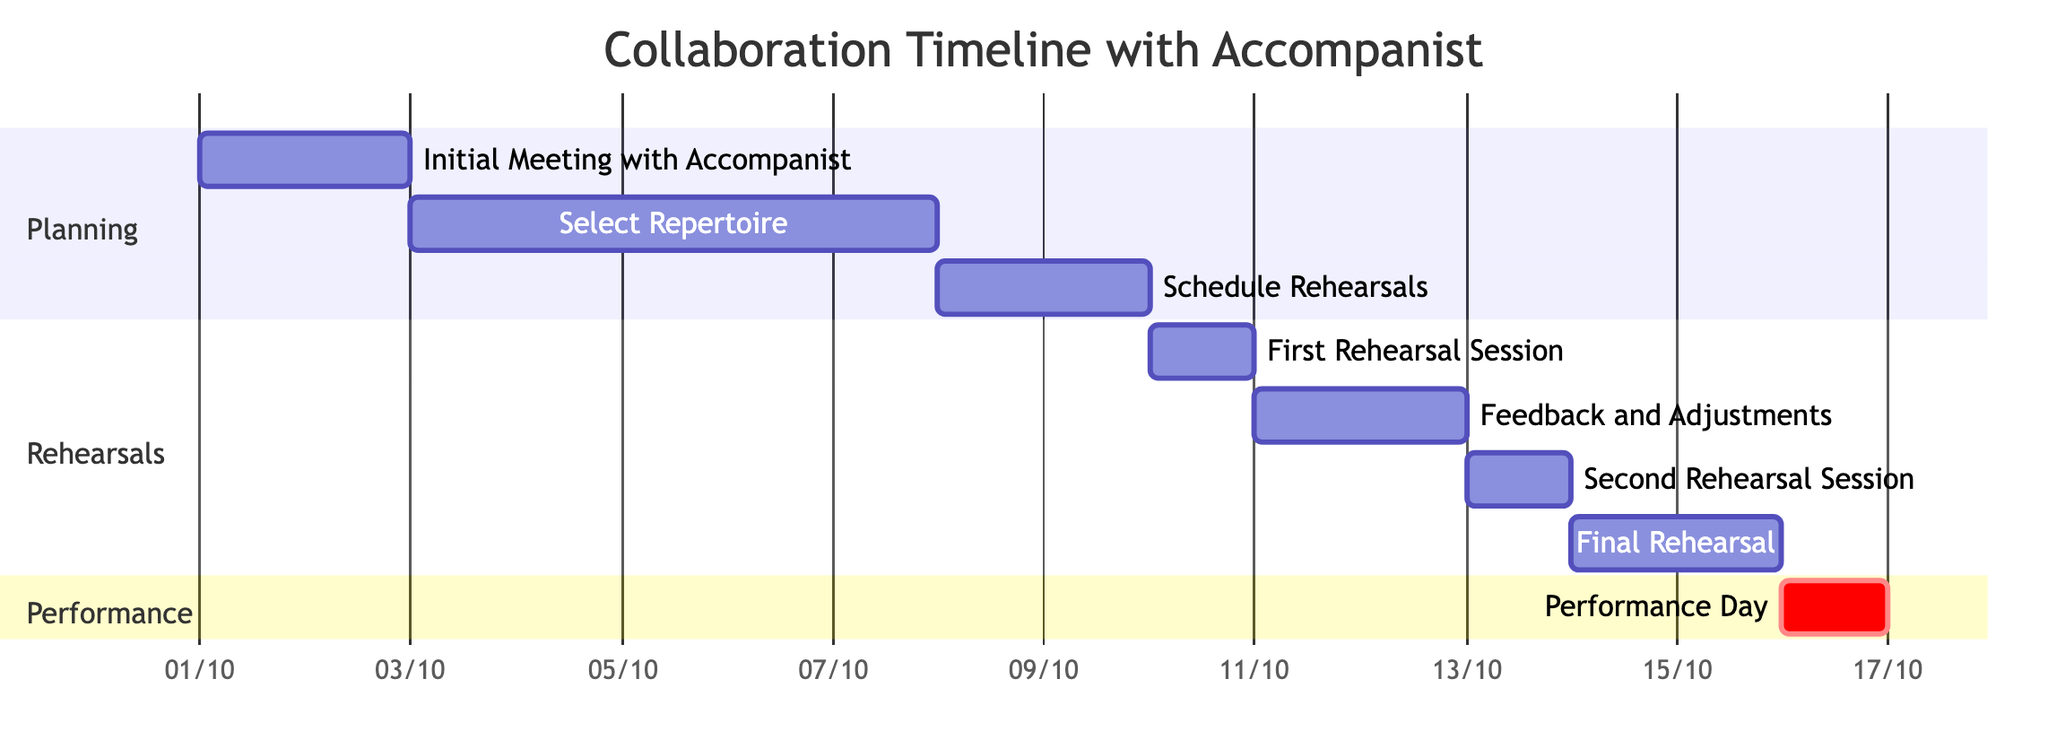What is the total number of tasks in the timeline? The timeline shows a total of eight tasks listed under three sections: Planning, Rehearsals, and Performance.
Answer: 8 Which task starts right after the first rehearsal session? The task "Feedback and Adjustments" starts immediately after "First Rehearsal Session" on October 11, 2023.
Answer: Feedback and Adjustments How many days does the "Select Repertoire" task last? The "Select Repertoire" task starts on October 3, 2023, and ends on October 7, 2023, lasting for a total of five days.
Answer: 5 days What task is scheduled for October 16, 2023? The "Performance Day" task is scheduled for October 16, 2023, as indicated in the diagram.
Answer: Performance Day How many rehearsal sessions are planned in total? There are three rehearsal sessions indicated: the "First Rehearsal Session," "Second Rehearsal Session," and "Final Rehearsal."
Answer: 3 What is the duration between the "Select Repertoire" and "First Rehearsal Session"? The "Select Repertoire" ends on October 7 and the "First Rehearsal Session" starts on October 10, resulting in a gap of two days.
Answer: 2 days Which task has the longest duration? The "Select Repertoire" task is the longest, lasting for five days.
Answer: Select Repertoire What are the tasks listed under the Rehearsals section? The tasks listed under the Rehearsals section include "First Rehearsal Session," "Feedback and Adjustments," "Second Rehearsal Session," and "Final Rehearsal."
Answer: First Rehearsal Session, Feedback and Adjustments, Second Rehearsal Session, Final Rehearsal On what date does the final rehearsal end? The "Final Rehearsal" task concludes on October 15, 2023.
Answer: October 15, 2023 